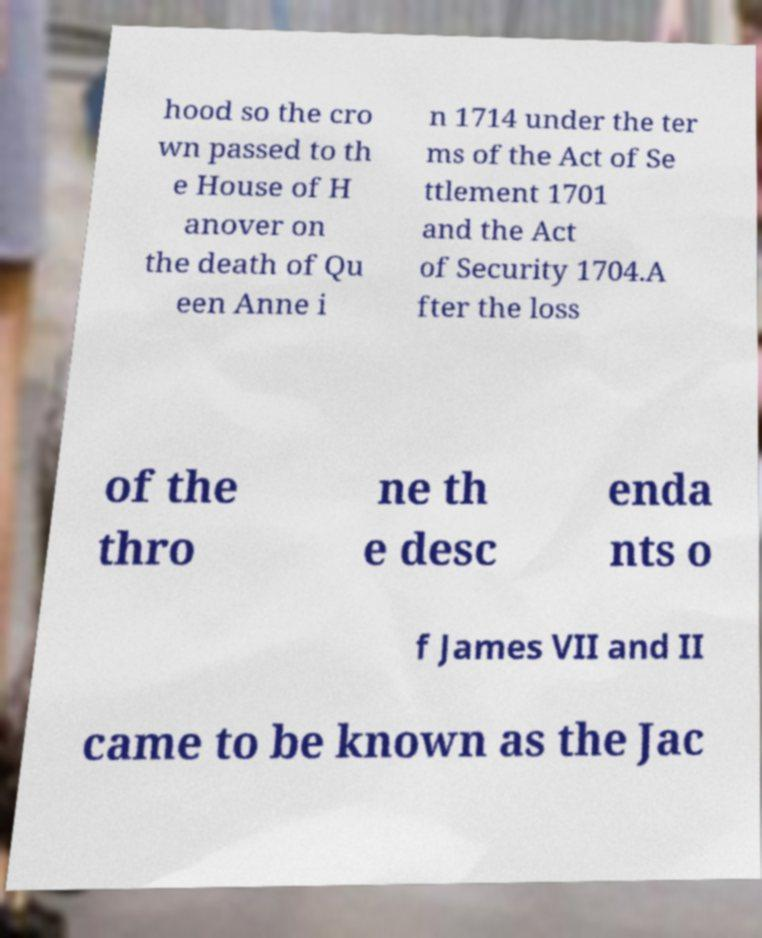Could you extract and type out the text from this image? hood so the cro wn passed to th e House of H anover on the death of Qu een Anne i n 1714 under the ter ms of the Act of Se ttlement 1701 and the Act of Security 1704.A fter the loss of the thro ne th e desc enda nts o f James VII and II came to be known as the Jac 